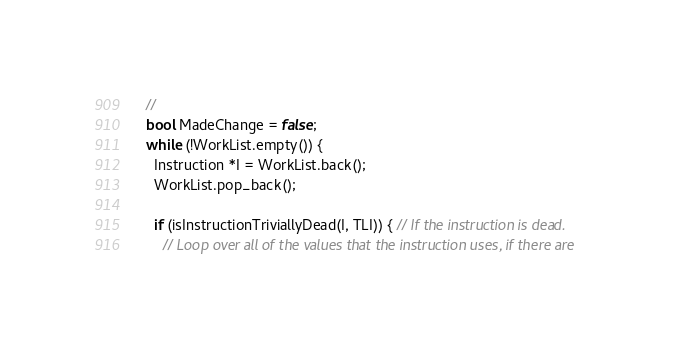Convert code to text. <code><loc_0><loc_0><loc_500><loc_500><_C++_>  //
  bool MadeChange = false;
  while (!WorkList.empty()) {
    Instruction *I = WorkList.back();
    WorkList.pop_back();

    if (isInstructionTriviallyDead(I, TLI)) { // If the instruction is dead.
      // Loop over all of the values that the instruction uses, if there are</code> 